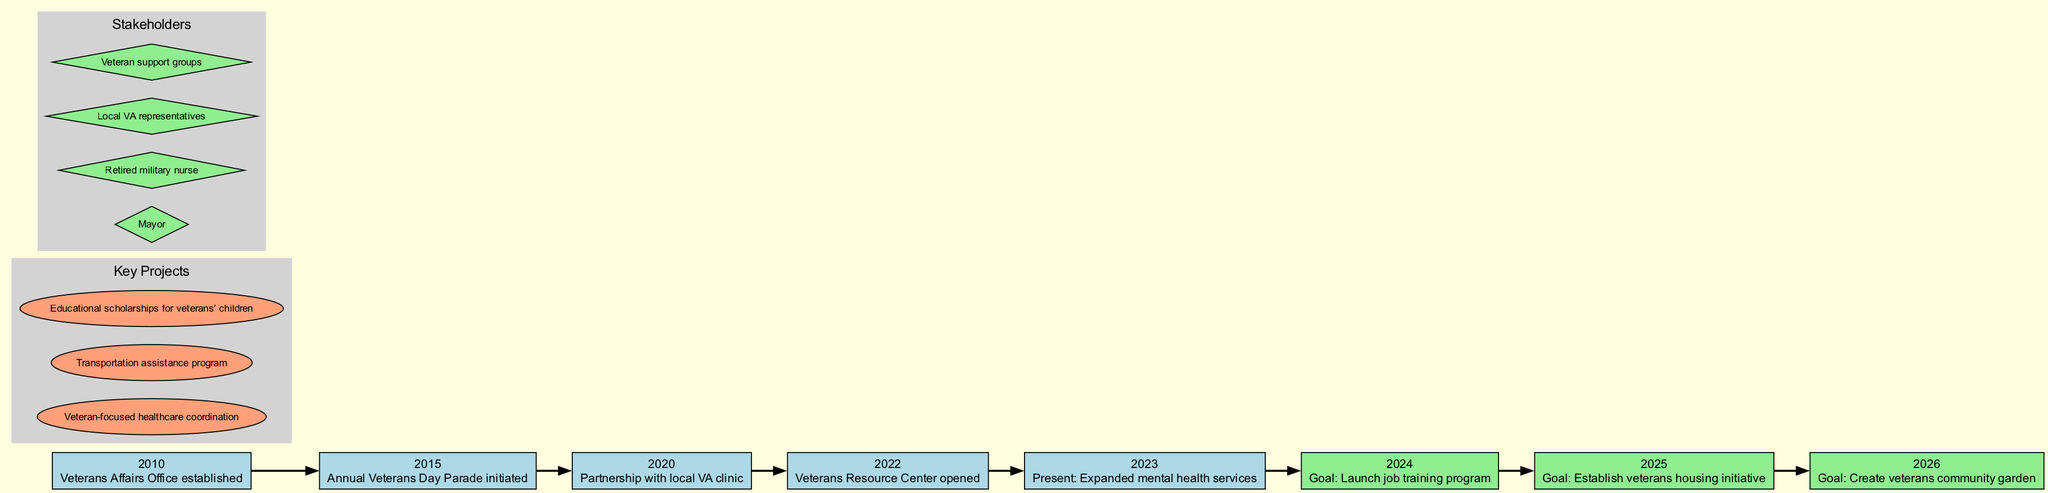What year was the Veterans Affairs Office established? According to the timeline, the Veterans Affairs Office was established in the year 2010, which is the first event listed.
Answer: 2010 What is the event listed for the year 2022? The diagram shows that in the year 2022, the event is "Veterans Resource Center opened", which is specifically noted in the timeline.
Answer: Veterans Resource Center opened How many total goals are set for the years 2024-2026? The timeline indicates three specific goals for the years 2024 (job training program), 2025 (housing initiative), and 2026 (community garden), thus totaling three goals.
Answer: 3 Which event occurs just before the expansion of mental health services? The diagram indicates that the event "Veterans Resource Center opened" in 2022 occurs just prior to the present focus on expanded mental health services in 2023.
Answer: Veterans Resource Center opened What shape represents stakeholders in the diagram? The diagram uses diamond shapes to represent stakeholders, as indicated by the subgraph for stakeholders within the diagram's structure.
Answer: Diamond What are the years in which goals are set according to the diagram? The timeline specifies the years 2024, 2025, and 2026, which are noted for future goals to be achieved as outlined in the diagram.
Answer: 2024, 2025, 2026 Is there a connection between the establishment of the Veterans Affairs Office and the opening of the Veterans Resource Center? Yes, there is a direct connection as the Veterans Affairs Office was established in 2010 and the Veterans Resource Center opened in 2022, indicating a long-term effort towards improving veteran support that connects these two events.
Answer: Yes What initiative is planned for the year 2025? The goal set for the year 2025 as outlined in the diagram is to establish a veterans housing initiative.
Answer: Establish veterans housing initiative How many key projects are mentioned in the diagram? The diagram lists three key projects focused on veteran support, as indicated by the subgraph for key projects.
Answer: 3 